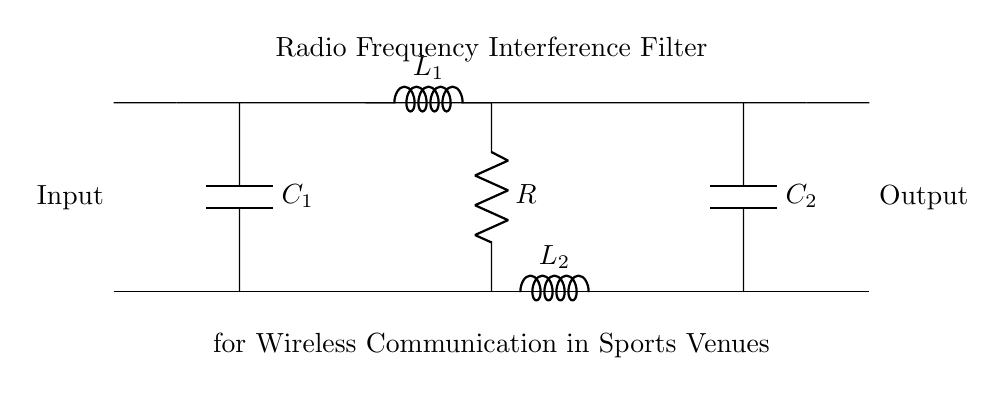What is the function of C1 in this circuit? C1 is a capacitor that helps filter out unwanted frequencies by providing a path to ground for those frequencies, thus allowing only desired signals to pass through.
Answer: filter unwanted frequencies How many inductors are present in this circuit? There are two inductors, L1 and L2, which are used to create a low-pass filter effect by impeding high-frequency signals.
Answer: two What is the value of the resistor in the circuit? The circuit diagram does not provide a numerical value for the resistor, only its label as R, indicating it is part of the filter network.
Answer: R What is the purpose of the inductor L1? L1 serves to block high-frequency currents while allowing lower-frequency signals to pass, helping in the interference filtering process.
Answer: block high frequencies What is the overall type of this circuit? This circuit is a radio frequency interference filter designed to suppress radio frequency interference while allowing desired signals to pass through.
Answer: interference filter How are C1 and C2 connected in this circuit? C1 and C2 are connected in parallel to the input lines, providing filtering capabilities on both the upper and lower signal paths.
Answer: in parallel What provides the main filtering effect in this circuit? The combination of capacitors and inductors (C1, C2, L1, and L2) works together to provide the main filtering effect by creating a resonant network tailored for specific frequency ranges.
Answer: capacitors and inductors 